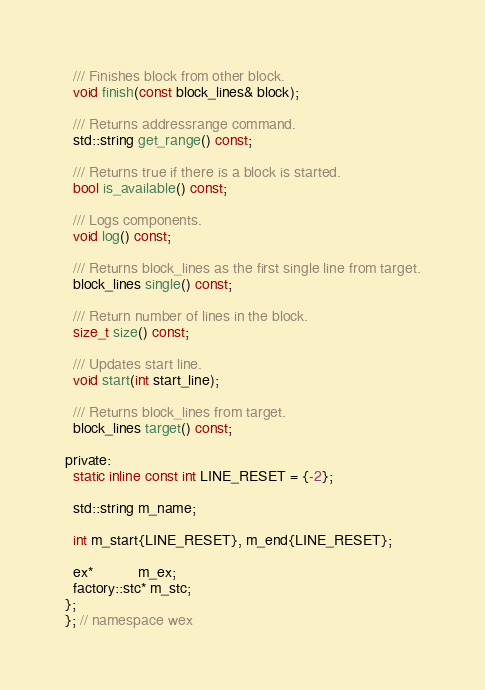Convert code to text. <code><loc_0><loc_0><loc_500><loc_500><_C_>  /// Finishes block from other block.
  void finish(const block_lines& block);

  /// Returns addressrange command.
  std::string get_range() const;

  /// Returns true if there is a block is started.
  bool is_available() const;

  /// Logs components.
  void log() const;

  /// Returns block_lines as the first single line from target.
  block_lines single() const;

  /// Return number of lines in the block.
  size_t size() const;

  /// Updates start line.
  void start(int start_line);

  /// Returns block_lines from target.
  block_lines target() const;

private:
  static inline const int LINE_RESET = {-2};

  std::string m_name;

  int m_start{LINE_RESET}, m_end{LINE_RESET};

  ex*           m_ex;
  factory::stc* m_stc;
};
}; // namespace wex
</code> 